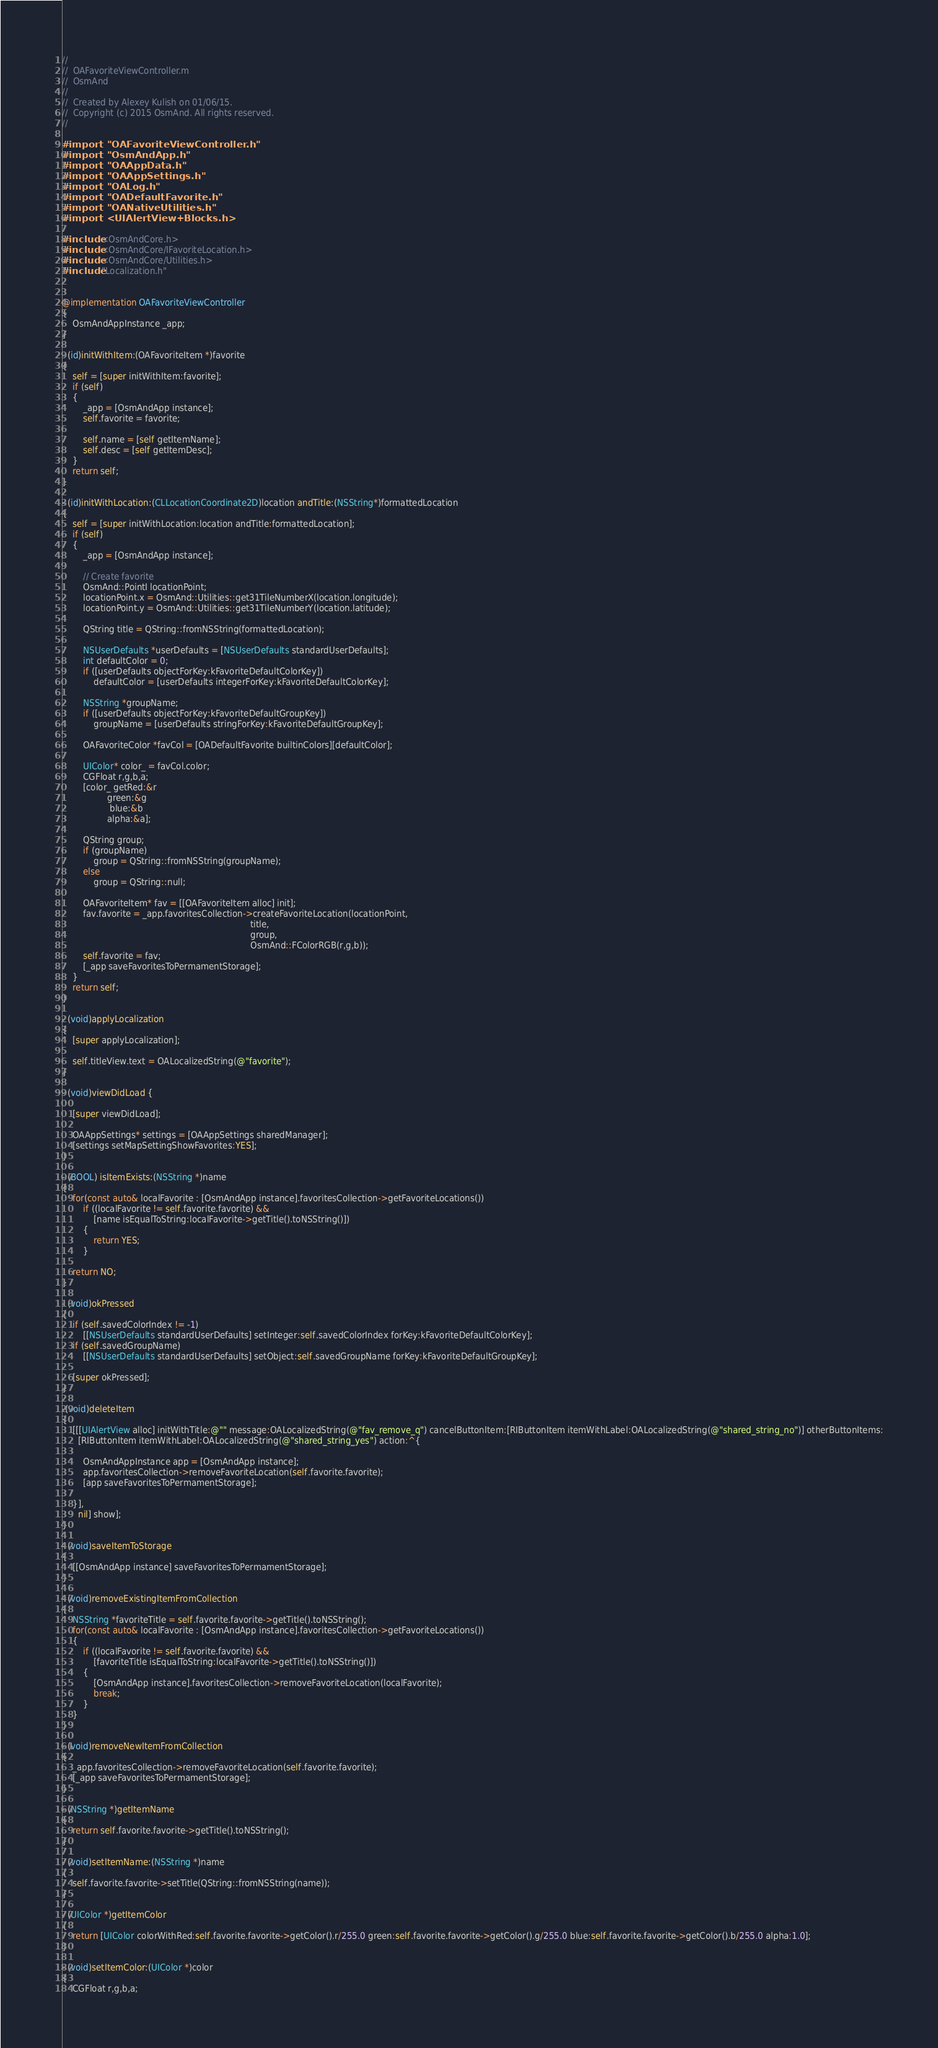<code> <loc_0><loc_0><loc_500><loc_500><_ObjectiveC_>//
//  OAFavoriteViewController.m
//  OsmAnd
//
//  Created by Alexey Kulish on 01/06/15.
//  Copyright (c) 2015 OsmAnd. All rights reserved.
//

#import "OAFavoriteViewController.h"
#import "OsmAndApp.h"
#import "OAAppData.h"
#import "OAAppSettings.h"
#import "OALog.h"
#import "OADefaultFavorite.h"
#import "OANativeUtilities.h"
#import <UIAlertView+Blocks.h>

#include <OsmAndCore.h>
#include <OsmAndCore/IFavoriteLocation.h>
#include <OsmAndCore/Utilities.h>
#include "Localization.h"


@implementation OAFavoriteViewController
{
    OsmAndAppInstance _app;
}

- (id)initWithItem:(OAFavoriteItem *)favorite
{
    self = [super initWithItem:favorite];
    if (self)
    {
        _app = [OsmAndApp instance];
        self.favorite = favorite;

        self.name = [self getItemName];
        self.desc = [self getItemDesc];
    }
    return self;
}

- (id)initWithLocation:(CLLocationCoordinate2D)location andTitle:(NSString*)formattedLocation
{
    self = [super initWithLocation:location andTitle:formattedLocation];
    if (self)
    {
        _app = [OsmAndApp instance];
        
        // Create favorite
        OsmAnd::PointI locationPoint;
        locationPoint.x = OsmAnd::Utilities::get31TileNumberX(location.longitude);
        locationPoint.y = OsmAnd::Utilities::get31TileNumberY(location.latitude);
        
        QString title = QString::fromNSString(formattedLocation);
        
        NSUserDefaults *userDefaults = [NSUserDefaults standardUserDefaults];
        int defaultColor = 0;
        if ([userDefaults objectForKey:kFavoriteDefaultColorKey])
            defaultColor = [userDefaults integerForKey:kFavoriteDefaultColorKey];
        
        NSString *groupName;
        if ([userDefaults objectForKey:kFavoriteDefaultGroupKey])
            groupName = [userDefaults stringForKey:kFavoriteDefaultGroupKey];
        
        OAFavoriteColor *favCol = [OADefaultFavorite builtinColors][defaultColor];
        
        UIColor* color_ = favCol.color;
        CGFloat r,g,b,a;
        [color_ getRed:&r
                 green:&g
                  blue:&b
                 alpha:&a];
        
        QString group;
        if (groupName)
            group = QString::fromNSString(groupName);
        else
            group = QString::null;
        
        OAFavoriteItem* fav = [[OAFavoriteItem alloc] init];
        fav.favorite = _app.favoritesCollection->createFavoriteLocation(locationPoint,
                                                                       title,
                                                                       group,
                                                                       OsmAnd::FColorRGB(r,g,b));
        self.favorite = fav;
        [_app saveFavoritesToPermamentStorage];
    }
    return self;
}

- (void)applyLocalization
{
    [super applyLocalization];
    
    self.titleView.text = OALocalizedString(@"favorite");
}

- (void)viewDidLoad {
    
    [super viewDidLoad];
    
    OAAppSettings* settings = [OAAppSettings sharedManager];
    [settings setMapSettingShowFavorites:YES];
}

- (BOOL) isItemExists:(NSString *)name
{
    for(const auto& localFavorite : [OsmAndApp instance].favoritesCollection->getFavoriteLocations())
        if ((localFavorite != self.favorite.favorite) &&
            [name isEqualToString:localFavorite->getTitle().toNSString()])
        {
            return YES;
        }
    
    return NO;
}

- (void)okPressed
{
    if (self.savedColorIndex != -1)
        [[NSUserDefaults standardUserDefaults] setInteger:self.savedColorIndex forKey:kFavoriteDefaultColorKey];
    if (self.savedGroupName)
        [[NSUserDefaults standardUserDefaults] setObject:self.savedGroupName forKey:kFavoriteDefaultGroupKey];
    
    [super okPressed];
}

-(void)deleteItem
{
    [[[UIAlertView alloc] initWithTitle:@"" message:OALocalizedString(@"fav_remove_q") cancelButtonItem:[RIButtonItem itemWithLabel:OALocalizedString(@"shared_string_no")] otherButtonItems:
      [RIButtonItem itemWithLabel:OALocalizedString(@"shared_string_yes") action:^{
        
        OsmAndAppInstance app = [OsmAndApp instance];
        app.favoritesCollection->removeFavoriteLocation(self.favorite.favorite);
        [app saveFavoritesToPermamentStorage];
        
    }],
      nil] show];
}

- (void)saveItemToStorage
{
    [[OsmAndApp instance] saveFavoritesToPermamentStorage];
}

- (void)removeExistingItemFromCollection
{
    NSString *favoriteTitle = self.favorite.favorite->getTitle().toNSString();
    for(const auto& localFavorite : [OsmAndApp instance].favoritesCollection->getFavoriteLocations())
    {
        if ((localFavorite != self.favorite.favorite) &&
            [favoriteTitle isEqualToString:localFavorite->getTitle().toNSString()])
        {
            [OsmAndApp instance].favoritesCollection->removeFavoriteLocation(localFavorite);
            break;
        }
    }
}

- (void)removeNewItemFromCollection
{
    _app.favoritesCollection->removeFavoriteLocation(self.favorite.favorite);
    [_app saveFavoritesToPermamentStorage];
}

- (NSString *)getItemName
{
    return self.favorite.favorite->getTitle().toNSString();
}

- (void)setItemName:(NSString *)name
{
    self.favorite.favorite->setTitle(QString::fromNSString(name));
}

- (UIColor *)getItemColor
{
    return [UIColor colorWithRed:self.favorite.favorite->getColor().r/255.0 green:self.favorite.favorite->getColor().g/255.0 blue:self.favorite.favorite->getColor().b/255.0 alpha:1.0];
}

- (void)setItemColor:(UIColor *)color
{
    CGFloat r,g,b,a;</code> 